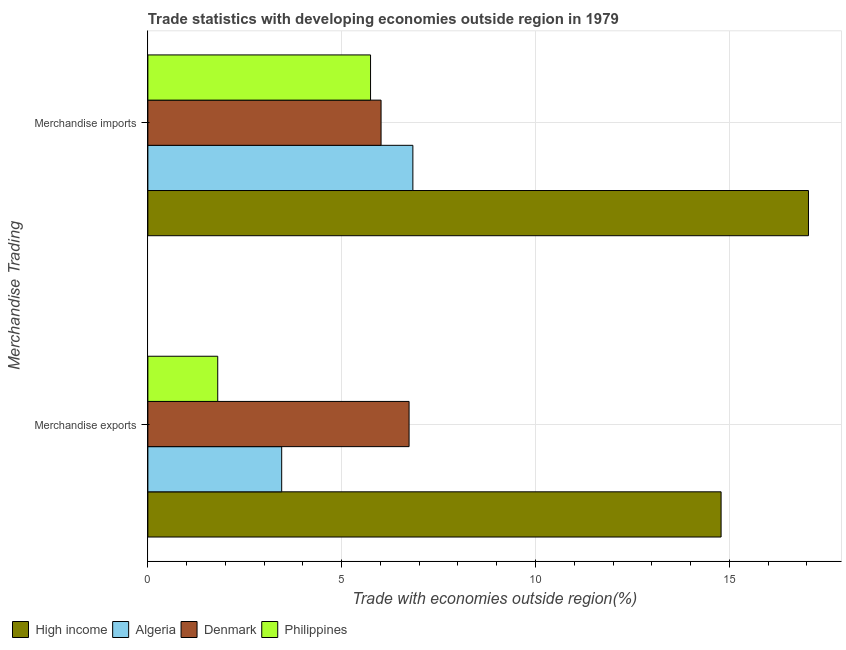How many different coloured bars are there?
Your response must be concise. 4. How many groups of bars are there?
Your response must be concise. 2. Are the number of bars per tick equal to the number of legend labels?
Provide a succinct answer. Yes. Are the number of bars on each tick of the Y-axis equal?
Make the answer very short. Yes. How many bars are there on the 1st tick from the bottom?
Make the answer very short. 4. What is the label of the 1st group of bars from the top?
Provide a succinct answer. Merchandise imports. What is the merchandise exports in Philippines?
Offer a very short reply. 1.8. Across all countries, what is the maximum merchandise imports?
Ensure brevity in your answer.  17.04. Across all countries, what is the minimum merchandise imports?
Provide a short and direct response. 5.75. In which country was the merchandise imports maximum?
Keep it short and to the point. High income. In which country was the merchandise exports minimum?
Give a very brief answer. Philippines. What is the total merchandise exports in the graph?
Keep it short and to the point. 26.78. What is the difference between the merchandise imports in Algeria and that in Philippines?
Give a very brief answer. 1.09. What is the difference between the merchandise imports in Philippines and the merchandise exports in Denmark?
Provide a short and direct response. -0.99. What is the average merchandise exports per country?
Make the answer very short. 6.7. What is the difference between the merchandise exports and merchandise imports in Denmark?
Your answer should be compact. 0.72. What is the ratio of the merchandise imports in Philippines to that in Denmark?
Give a very brief answer. 0.95. Is the merchandise exports in High income less than that in Philippines?
Give a very brief answer. No. What does the 3rd bar from the top in Merchandise imports represents?
Provide a short and direct response. Algeria. What does the 4th bar from the bottom in Merchandise imports represents?
Your answer should be compact. Philippines. How many bars are there?
Keep it short and to the point. 8. Are all the bars in the graph horizontal?
Provide a succinct answer. Yes. What is the difference between two consecutive major ticks on the X-axis?
Your response must be concise. 5. Are the values on the major ticks of X-axis written in scientific E-notation?
Provide a succinct answer. No. Does the graph contain any zero values?
Your answer should be compact. No. Does the graph contain grids?
Provide a short and direct response. Yes. Where does the legend appear in the graph?
Provide a succinct answer. Bottom left. How many legend labels are there?
Keep it short and to the point. 4. How are the legend labels stacked?
Provide a succinct answer. Horizontal. What is the title of the graph?
Offer a very short reply. Trade statistics with developing economies outside region in 1979. What is the label or title of the X-axis?
Your response must be concise. Trade with economies outside region(%). What is the label or title of the Y-axis?
Offer a very short reply. Merchandise Trading. What is the Trade with economies outside region(%) of High income in Merchandise exports?
Your response must be concise. 14.79. What is the Trade with economies outside region(%) in Algeria in Merchandise exports?
Provide a succinct answer. 3.45. What is the Trade with economies outside region(%) of Denmark in Merchandise exports?
Your answer should be compact. 6.74. What is the Trade with economies outside region(%) in Philippines in Merchandise exports?
Your response must be concise. 1.8. What is the Trade with economies outside region(%) of High income in Merchandise imports?
Make the answer very short. 17.04. What is the Trade with economies outside region(%) of Algeria in Merchandise imports?
Keep it short and to the point. 6.84. What is the Trade with economies outside region(%) in Denmark in Merchandise imports?
Offer a very short reply. 6.02. What is the Trade with economies outside region(%) of Philippines in Merchandise imports?
Your answer should be compact. 5.75. Across all Merchandise Trading, what is the maximum Trade with economies outside region(%) of High income?
Provide a short and direct response. 17.04. Across all Merchandise Trading, what is the maximum Trade with economies outside region(%) of Algeria?
Your response must be concise. 6.84. Across all Merchandise Trading, what is the maximum Trade with economies outside region(%) of Denmark?
Offer a terse response. 6.74. Across all Merchandise Trading, what is the maximum Trade with economies outside region(%) of Philippines?
Keep it short and to the point. 5.75. Across all Merchandise Trading, what is the minimum Trade with economies outside region(%) in High income?
Provide a succinct answer. 14.79. Across all Merchandise Trading, what is the minimum Trade with economies outside region(%) in Algeria?
Provide a short and direct response. 3.45. Across all Merchandise Trading, what is the minimum Trade with economies outside region(%) of Denmark?
Give a very brief answer. 6.02. Across all Merchandise Trading, what is the minimum Trade with economies outside region(%) of Philippines?
Offer a terse response. 1.8. What is the total Trade with economies outside region(%) in High income in the graph?
Give a very brief answer. 31.83. What is the total Trade with economies outside region(%) in Algeria in the graph?
Keep it short and to the point. 10.29. What is the total Trade with economies outside region(%) of Denmark in the graph?
Offer a terse response. 12.76. What is the total Trade with economies outside region(%) of Philippines in the graph?
Your response must be concise. 7.55. What is the difference between the Trade with economies outside region(%) of High income in Merchandise exports and that in Merchandise imports?
Provide a short and direct response. -2.25. What is the difference between the Trade with economies outside region(%) of Algeria in Merchandise exports and that in Merchandise imports?
Your response must be concise. -3.38. What is the difference between the Trade with economies outside region(%) in Denmark in Merchandise exports and that in Merchandise imports?
Provide a short and direct response. 0.72. What is the difference between the Trade with economies outside region(%) of Philippines in Merchandise exports and that in Merchandise imports?
Keep it short and to the point. -3.94. What is the difference between the Trade with economies outside region(%) of High income in Merchandise exports and the Trade with economies outside region(%) of Algeria in Merchandise imports?
Make the answer very short. 7.95. What is the difference between the Trade with economies outside region(%) in High income in Merchandise exports and the Trade with economies outside region(%) in Denmark in Merchandise imports?
Provide a short and direct response. 8.77. What is the difference between the Trade with economies outside region(%) of High income in Merchandise exports and the Trade with economies outside region(%) of Philippines in Merchandise imports?
Provide a short and direct response. 9.04. What is the difference between the Trade with economies outside region(%) of Algeria in Merchandise exports and the Trade with economies outside region(%) of Denmark in Merchandise imports?
Your response must be concise. -2.56. What is the difference between the Trade with economies outside region(%) of Algeria in Merchandise exports and the Trade with economies outside region(%) of Philippines in Merchandise imports?
Provide a short and direct response. -2.29. What is the difference between the Trade with economies outside region(%) in Denmark in Merchandise exports and the Trade with economies outside region(%) in Philippines in Merchandise imports?
Offer a terse response. 0.99. What is the average Trade with economies outside region(%) of High income per Merchandise Trading?
Keep it short and to the point. 15.92. What is the average Trade with economies outside region(%) of Algeria per Merchandise Trading?
Make the answer very short. 5.14. What is the average Trade with economies outside region(%) in Denmark per Merchandise Trading?
Provide a short and direct response. 6.38. What is the average Trade with economies outside region(%) in Philippines per Merchandise Trading?
Your answer should be very brief. 3.77. What is the difference between the Trade with economies outside region(%) in High income and Trade with economies outside region(%) in Algeria in Merchandise exports?
Your answer should be very brief. 11.34. What is the difference between the Trade with economies outside region(%) in High income and Trade with economies outside region(%) in Denmark in Merchandise exports?
Provide a succinct answer. 8.05. What is the difference between the Trade with economies outside region(%) of High income and Trade with economies outside region(%) of Philippines in Merchandise exports?
Provide a short and direct response. 12.99. What is the difference between the Trade with economies outside region(%) of Algeria and Trade with economies outside region(%) of Denmark in Merchandise exports?
Provide a short and direct response. -3.29. What is the difference between the Trade with economies outside region(%) of Algeria and Trade with economies outside region(%) of Philippines in Merchandise exports?
Provide a short and direct response. 1.65. What is the difference between the Trade with economies outside region(%) in Denmark and Trade with economies outside region(%) in Philippines in Merchandise exports?
Provide a succinct answer. 4.94. What is the difference between the Trade with economies outside region(%) of High income and Trade with economies outside region(%) of Algeria in Merchandise imports?
Keep it short and to the point. 10.21. What is the difference between the Trade with economies outside region(%) of High income and Trade with economies outside region(%) of Denmark in Merchandise imports?
Make the answer very short. 11.03. What is the difference between the Trade with economies outside region(%) in High income and Trade with economies outside region(%) in Philippines in Merchandise imports?
Offer a terse response. 11.3. What is the difference between the Trade with economies outside region(%) of Algeria and Trade with economies outside region(%) of Denmark in Merchandise imports?
Your response must be concise. 0.82. What is the difference between the Trade with economies outside region(%) in Algeria and Trade with economies outside region(%) in Philippines in Merchandise imports?
Keep it short and to the point. 1.09. What is the difference between the Trade with economies outside region(%) of Denmark and Trade with economies outside region(%) of Philippines in Merchandise imports?
Your answer should be very brief. 0.27. What is the ratio of the Trade with economies outside region(%) in High income in Merchandise exports to that in Merchandise imports?
Your answer should be very brief. 0.87. What is the ratio of the Trade with economies outside region(%) of Algeria in Merchandise exports to that in Merchandise imports?
Keep it short and to the point. 0.5. What is the ratio of the Trade with economies outside region(%) of Denmark in Merchandise exports to that in Merchandise imports?
Provide a short and direct response. 1.12. What is the ratio of the Trade with economies outside region(%) in Philippines in Merchandise exports to that in Merchandise imports?
Make the answer very short. 0.31. What is the difference between the highest and the second highest Trade with economies outside region(%) in High income?
Provide a succinct answer. 2.25. What is the difference between the highest and the second highest Trade with economies outside region(%) in Algeria?
Give a very brief answer. 3.38. What is the difference between the highest and the second highest Trade with economies outside region(%) in Denmark?
Provide a succinct answer. 0.72. What is the difference between the highest and the second highest Trade with economies outside region(%) of Philippines?
Offer a terse response. 3.94. What is the difference between the highest and the lowest Trade with economies outside region(%) of High income?
Provide a short and direct response. 2.25. What is the difference between the highest and the lowest Trade with economies outside region(%) in Algeria?
Give a very brief answer. 3.38. What is the difference between the highest and the lowest Trade with economies outside region(%) in Denmark?
Your answer should be compact. 0.72. What is the difference between the highest and the lowest Trade with economies outside region(%) of Philippines?
Keep it short and to the point. 3.94. 